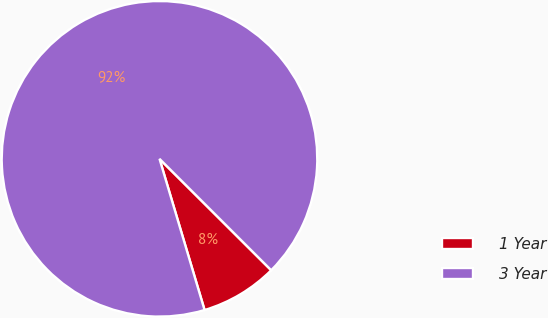<chart> <loc_0><loc_0><loc_500><loc_500><pie_chart><fcel>1 Year<fcel>3 Year<nl><fcel>7.91%<fcel>92.09%<nl></chart> 